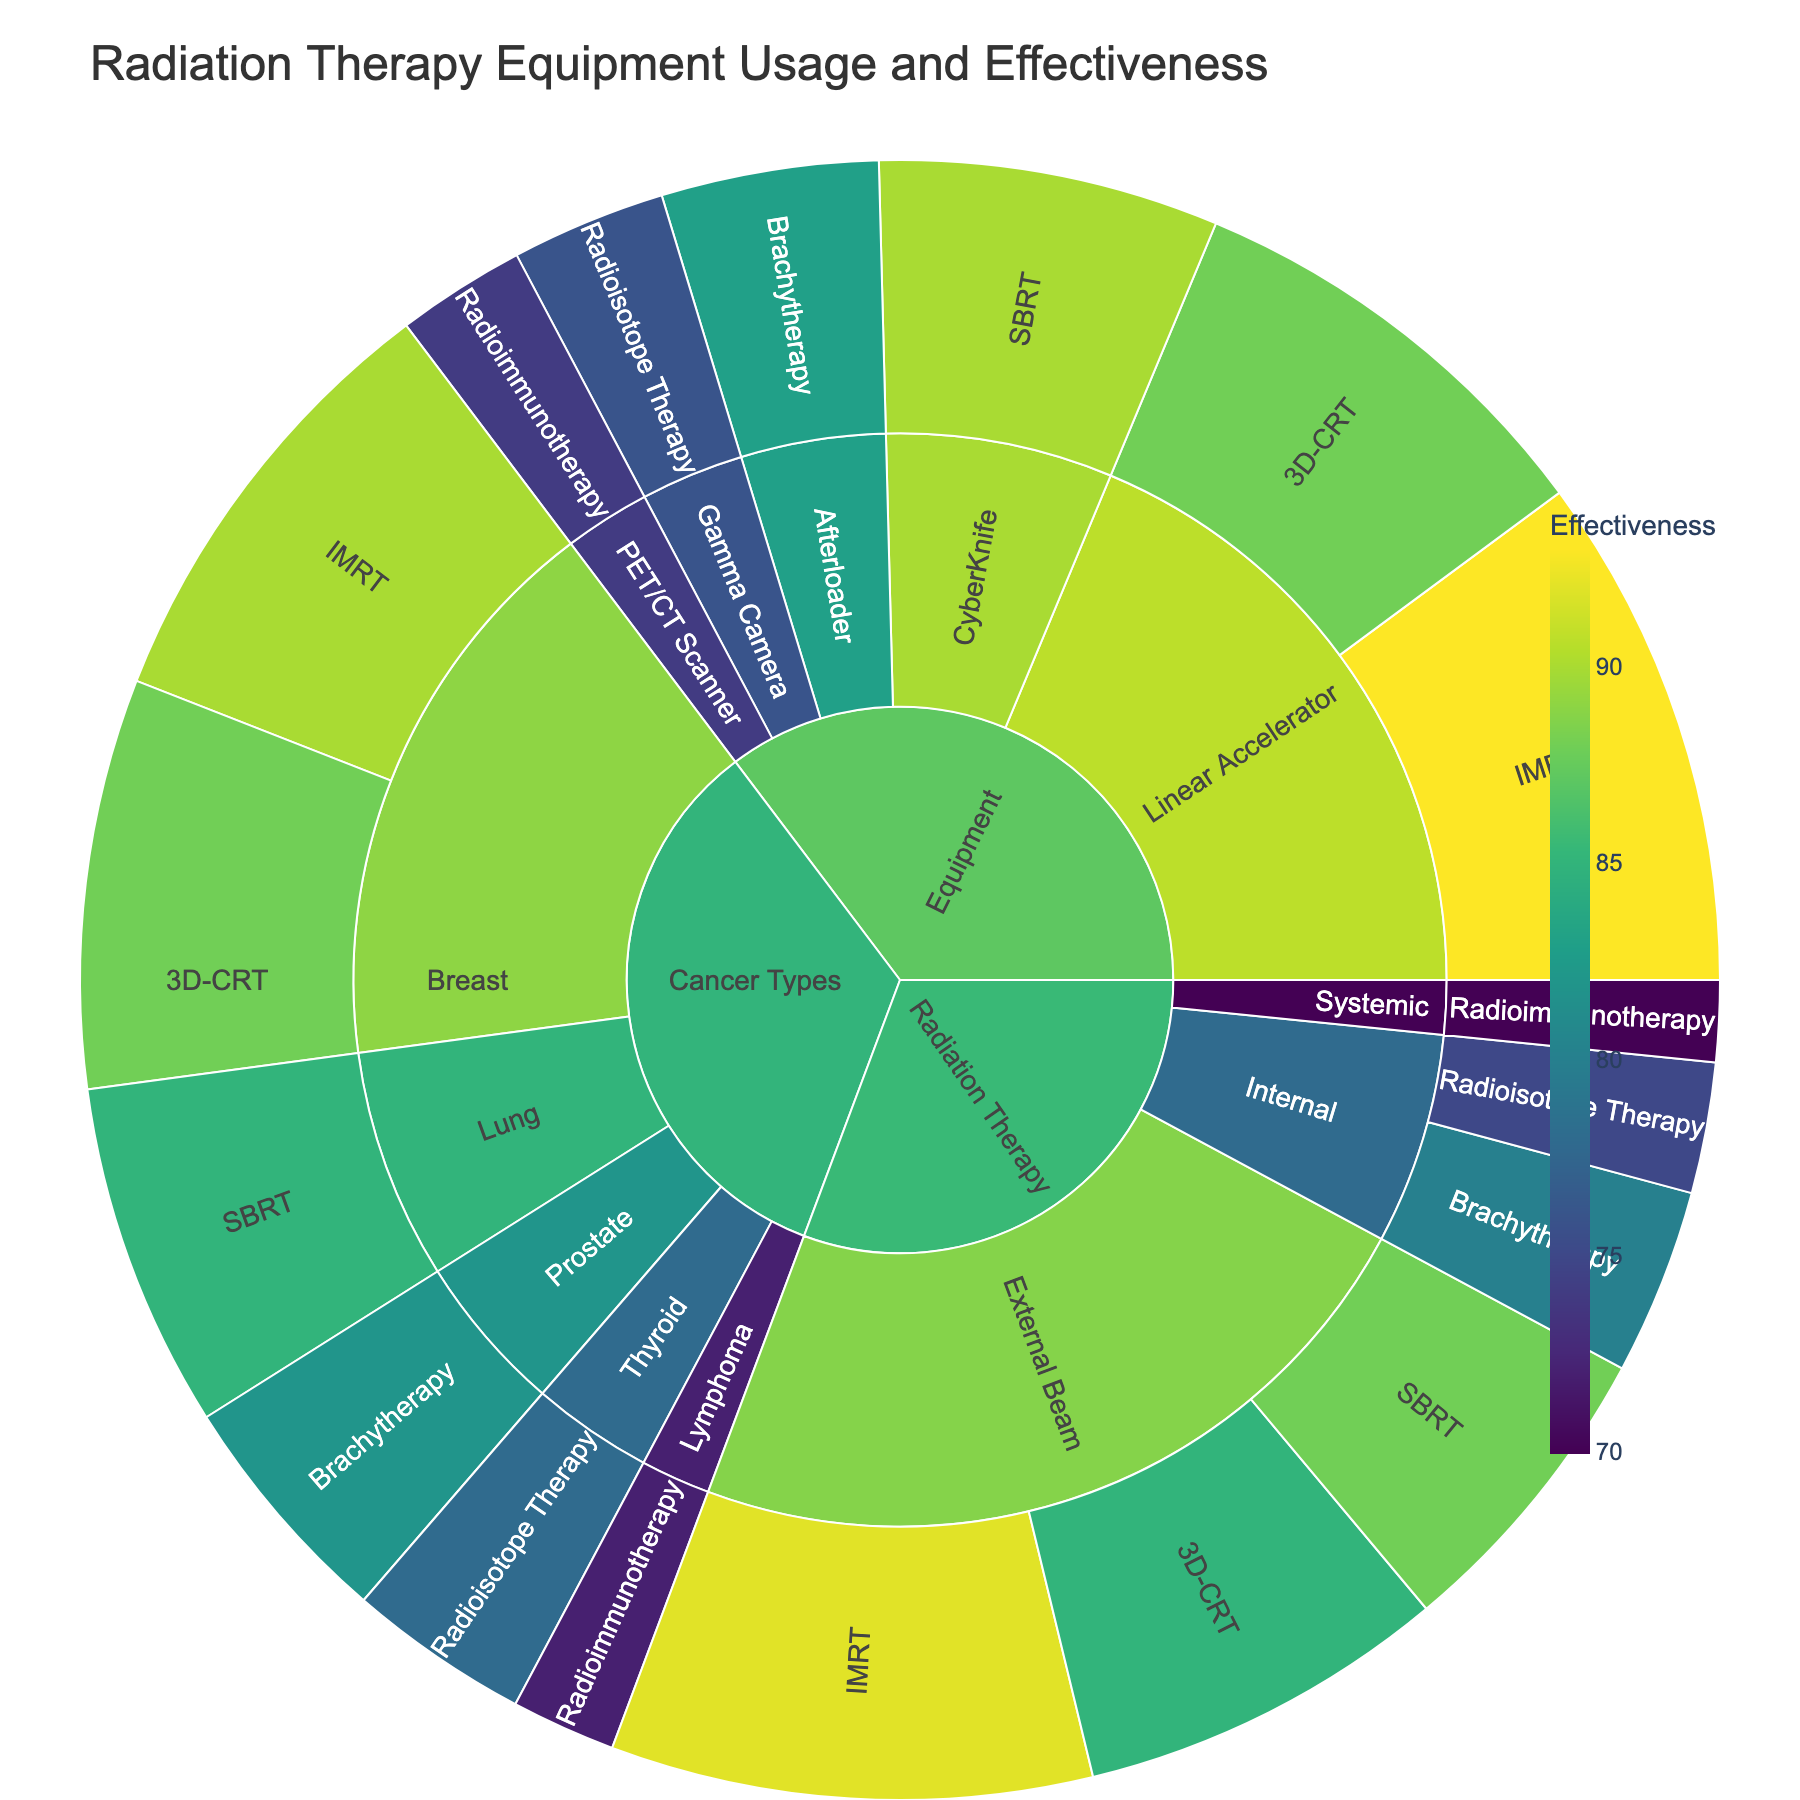Which treatment has the highest effectiveness? Look for the treatment with the highest effectiveness value. "IMRT" under the subcategory "External Beam" has the highest effectiveness of 92%.
Answer: IMRT What's the title of the sunburst plot? The title is usually displayed at the top of the plot. It reads "Radiation Therapy Equipment Usage and Effectiveness".
Answer: Radiation Therapy Equipment Usage and Effectiveness Compare the effectiveness of Brachytherapy in the "Internal" category and the "Prostate" cancer type. Which is higher? Identify the effectiveness values for Brachytherapy under both categories. Brachytherapy under "Internal" is 80% and under "Prostate" is 82%. Compare these values.
Answer: Prostate What subcategory under "Radiation Therapy" has the least usage? Look for the subcategory with the smallest usage value under "Radiation Therapy". "Radioimmunotherapy" has the least usage with 20%.
Answer: Radioimmunotherapy What is the total usage for "3D-CRT" across all categories? Sum the usage values of "3D-CRT" under each category: 75 ("External Beam") + 80 ("Breast") + 85 ("Linear Accelerator"). The total is 240.
Answer: 240 How does the effectiveness of treatments in the "Cancer Types" category compare to those in the "Equipment" category? Compare the effectiveness values of treatments under "Cancer Types" and "Equipment". Generally, treatments under "Equipment" show higher effectiveness values compared to those under "Cancer Types".
Answer: Equipment Identify the color scheme used in the plot. The color scheme is mentioned in the plot settings. It uses the "Viridis" color scale, which ranges from yellow to green to blue based on effectiveness.
Answer: Viridis What is the effectiveness of SBRT under "Lung" cancer type? Locate "SBRT" under the subcategory "Lung" within "Cancer Types". The effectiveness value is 85%.
Answer: 85 Which cancer type uses "Radioisotope Therapy"? Look for "Radioisotope Therapy" under the "Cancer Types" category. Thyroid cancer uses this treatment.
Answer: Thyroid Calculate the average effectiveness of all treatments under "External Beam". Add the effectiveness values of treatments under "External Beam" and divide by the number of treatments: (85 + 92 + 88) / 3 = 88.33%.
Answer: 88.33% 